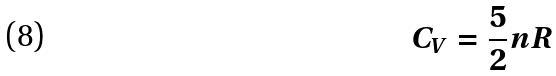Convert formula to latex. <formula><loc_0><loc_0><loc_500><loc_500>C _ { V } = \frac { 5 } { 2 } n R</formula> 